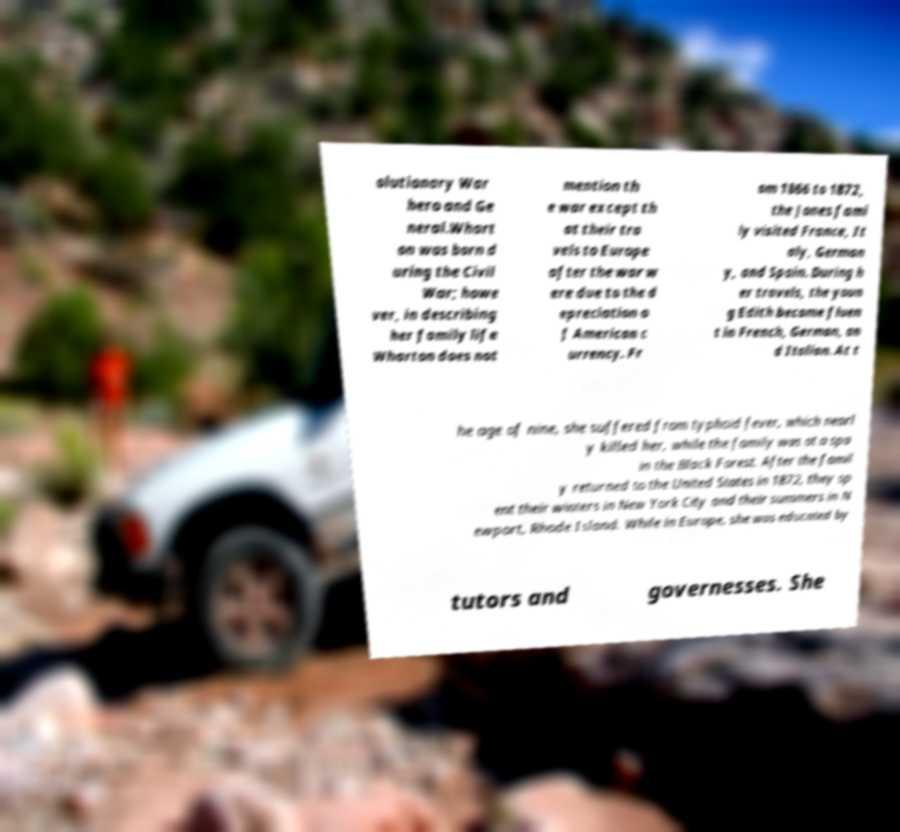For documentation purposes, I need the text within this image transcribed. Could you provide that? olutionary War hero and Ge neral.Whart on was born d uring the Civil War; howe ver, in describing her family life Wharton does not mention th e war except th at their tra vels to Europe after the war w ere due to the d epreciation o f American c urrency. Fr om 1866 to 1872, the Jones fami ly visited France, It aly, German y, and Spain. During h er travels, the youn g Edith became fluen t in French, German, an d Italian. At t he age of nine, she suffered from typhoid fever, which nearl y killed her, while the family was at a spa in the Black Forest. After the famil y returned to the United States in 1872, they sp ent their winters in New York City and their summers in N ewport, Rhode Island. While in Europe, she was educated by tutors and governesses. She 